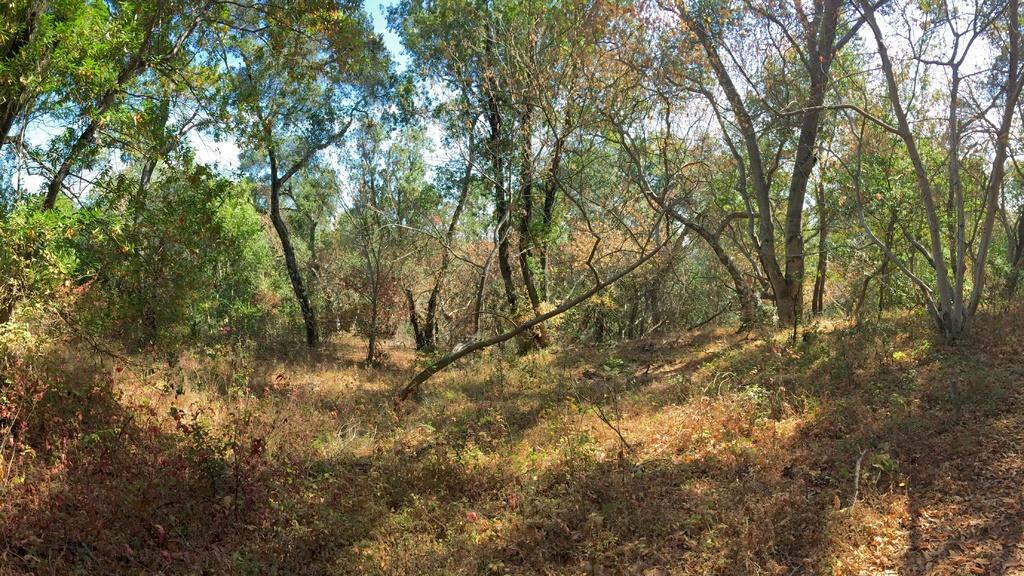What type of vegetation can be seen in the image? There are trees in the image. What else can be seen on the ground in the image? There is grass in the image. What colors are present in the sky in the image? The sky is blue and white in color. What type of quilt is being used to support the trees in the image? There is no quilt present in the image, nor is there any support for the trees. How does the comb help the grass grow in the image? There is no comb present in the image, and the grass does not require a comb to grow. 